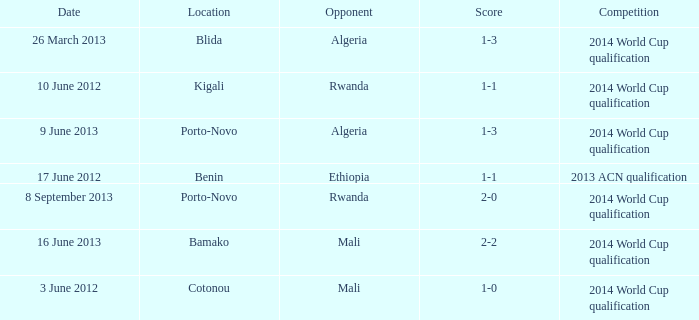Parse the full table. {'header': ['Date', 'Location', 'Opponent', 'Score', 'Competition'], 'rows': [['26 March 2013', 'Blida', 'Algeria', '1-3', '2014 World Cup qualification'], ['10 June 2012', 'Kigali', 'Rwanda', '1-1', '2014 World Cup qualification'], ['9 June 2013', 'Porto-Novo', 'Algeria', '1-3', '2014 World Cup qualification'], ['17 June 2012', 'Benin', 'Ethiopia', '1-1', '2013 ACN qualification'], ['8 September 2013', 'Porto-Novo', 'Rwanda', '2-0', '2014 World Cup qualification'], ['16 June 2013', 'Bamako', 'Mali', '2-2', '2014 World Cup qualification'], ['3 June 2012', 'Cotonou', 'Mali', '1-0', '2014 World Cup qualification']]} In bamako, what competitive event can be found? 2014 World Cup qualification. 